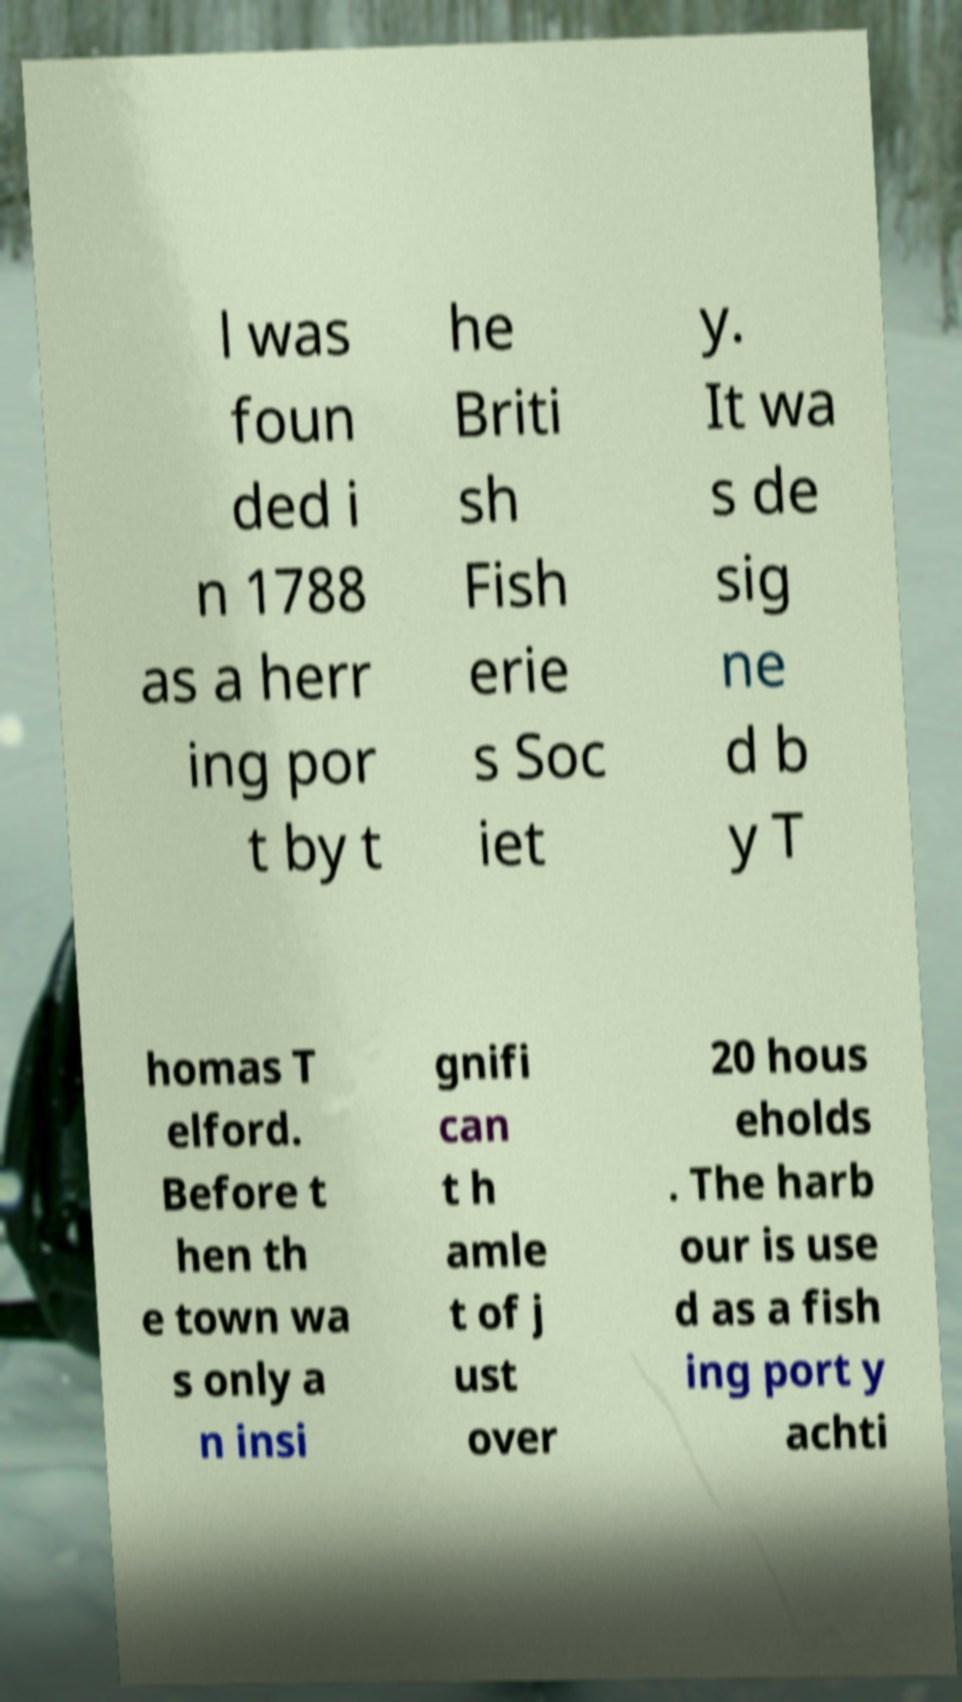Please identify and transcribe the text found in this image. l was foun ded i n 1788 as a herr ing por t by t he Briti sh Fish erie s Soc iet y. It wa s de sig ne d b y T homas T elford. Before t hen th e town wa s only a n insi gnifi can t h amle t of j ust over 20 hous eholds . The harb our is use d as a fish ing port y achti 